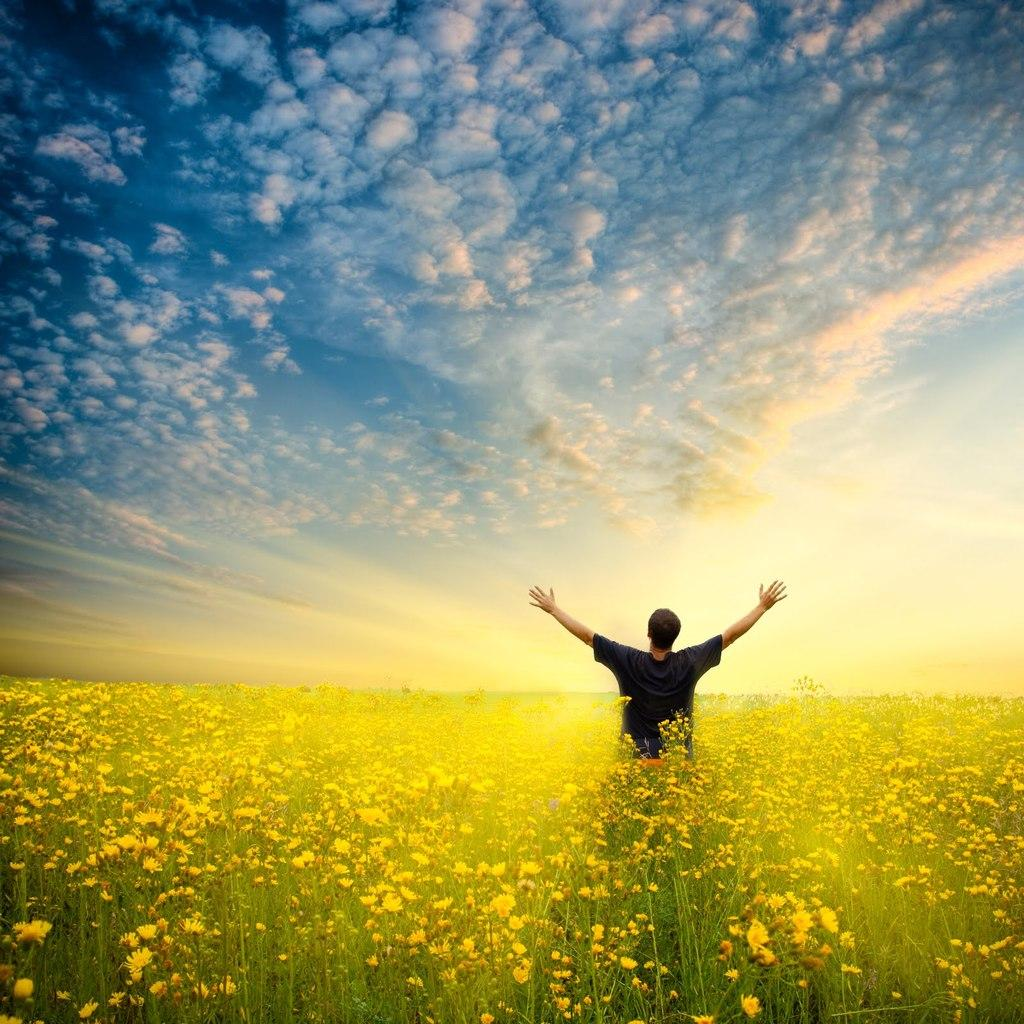Who is the main subject in the image? There is a man standing in the center of the image. What can be seen at the bottom of the image? There are plants and flowers at the bottom of the image. What is visible at the top of the image? The sky is visible at the top of the image. What type of marble is used to decorate the side of the image? There is no marble present in the image; it features a man, plants and flowers, and the sky. Which flower is blooming the most in the image? The image does not specify which flower is blooming the most, as it only mentions the presence of plants and flowers in general. 